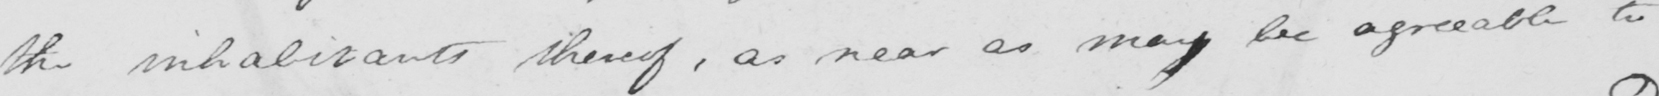Please transcribe the handwritten text in this image. the inhabitants thereof , as near as may be agreeable to 